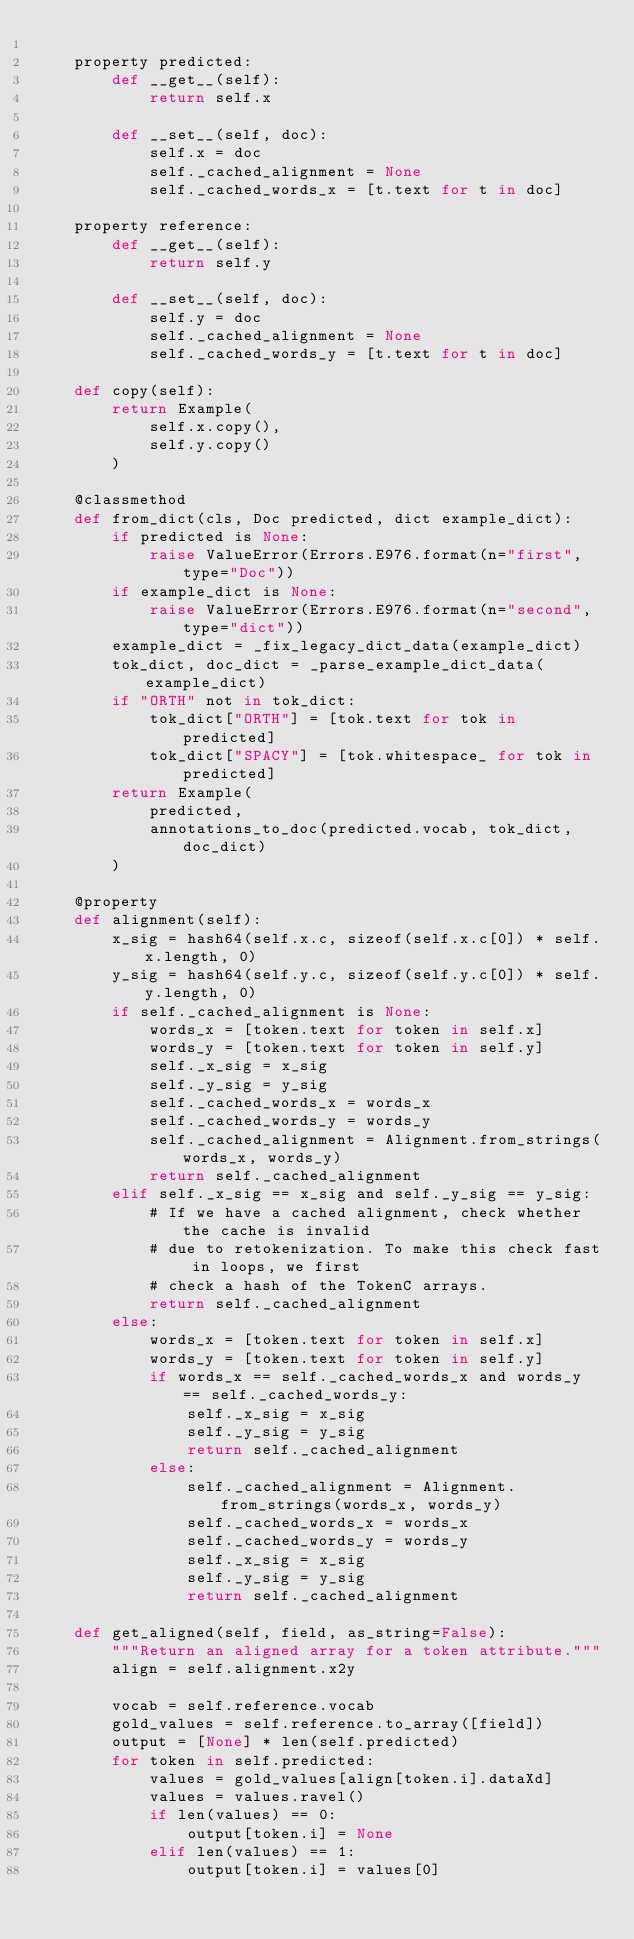Convert code to text. <code><loc_0><loc_0><loc_500><loc_500><_Cython_>
    property predicted:
        def __get__(self):
            return self.x

        def __set__(self, doc):
            self.x = doc
            self._cached_alignment = None
            self._cached_words_x = [t.text for t in doc]

    property reference:
        def __get__(self):
            return self.y

        def __set__(self, doc):
            self.y = doc
            self._cached_alignment = None
            self._cached_words_y = [t.text for t in doc]

    def copy(self):
        return Example(
            self.x.copy(),
            self.y.copy()
        )

    @classmethod
    def from_dict(cls, Doc predicted, dict example_dict):
        if predicted is None:
            raise ValueError(Errors.E976.format(n="first", type="Doc"))
        if example_dict is None:
            raise ValueError(Errors.E976.format(n="second", type="dict"))
        example_dict = _fix_legacy_dict_data(example_dict)
        tok_dict, doc_dict = _parse_example_dict_data(example_dict)
        if "ORTH" not in tok_dict:
            tok_dict["ORTH"] = [tok.text for tok in predicted]
            tok_dict["SPACY"] = [tok.whitespace_ for tok in predicted]
        return Example(
            predicted,
            annotations_to_doc(predicted.vocab, tok_dict, doc_dict)
        )

    @property
    def alignment(self):
        x_sig = hash64(self.x.c, sizeof(self.x.c[0]) * self.x.length, 0)
        y_sig = hash64(self.y.c, sizeof(self.y.c[0]) * self.y.length, 0)
        if self._cached_alignment is None:
            words_x = [token.text for token in self.x]
            words_y = [token.text for token in self.y]
            self._x_sig = x_sig
            self._y_sig = y_sig
            self._cached_words_x = words_x
            self._cached_words_y = words_y
            self._cached_alignment = Alignment.from_strings(words_x, words_y)
            return self._cached_alignment
        elif self._x_sig == x_sig and self._y_sig == y_sig:
            # If we have a cached alignment, check whether the cache is invalid
            # due to retokenization. To make this check fast in loops, we first
            # check a hash of the TokenC arrays.
            return self._cached_alignment
        else:
            words_x = [token.text for token in self.x]
            words_y = [token.text for token in self.y]
            if words_x == self._cached_words_x and words_y == self._cached_words_y:
                self._x_sig = x_sig
                self._y_sig = y_sig
                return self._cached_alignment
            else:
                self._cached_alignment = Alignment.from_strings(words_x, words_y)
                self._cached_words_x = words_x
                self._cached_words_y = words_y
                self._x_sig = x_sig
                self._y_sig = y_sig
                return self._cached_alignment

    def get_aligned(self, field, as_string=False):
        """Return an aligned array for a token attribute."""
        align = self.alignment.x2y

        vocab = self.reference.vocab
        gold_values = self.reference.to_array([field])
        output = [None] * len(self.predicted)
        for token in self.predicted:
            values = gold_values[align[token.i].dataXd]
            values = values.ravel()
            if len(values) == 0:
                output[token.i] = None
            elif len(values) == 1:
                output[token.i] = values[0]</code> 